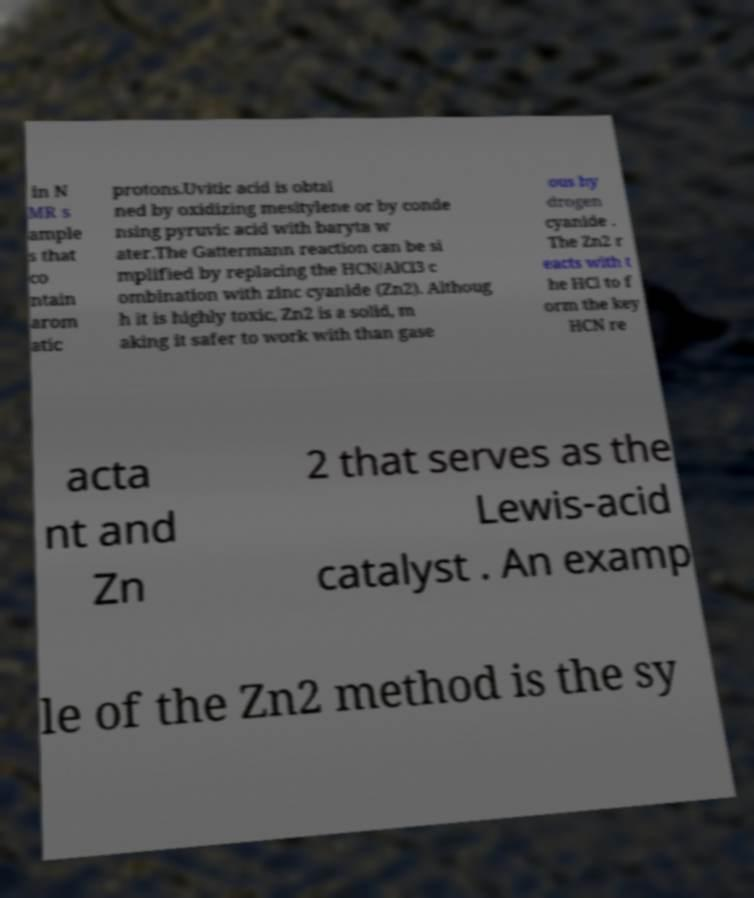Can you accurately transcribe the text from the provided image for me? in N MR s ample s that co ntain arom atic protons.Uvitic acid is obtai ned by oxidizing mesitylene or by conde nsing pyruvic acid with baryta w ater.The Gattermann reaction can be si mplified by replacing the HCN/AlCl3 c ombination with zinc cyanide (Zn2). Althoug h it is highly toxic, Zn2 is a solid, m aking it safer to work with than gase ous hy drogen cyanide . The Zn2 r eacts with t he HCl to f orm the key HCN re acta nt and Zn 2 that serves as the Lewis-acid catalyst . An examp le of the Zn2 method is the sy 